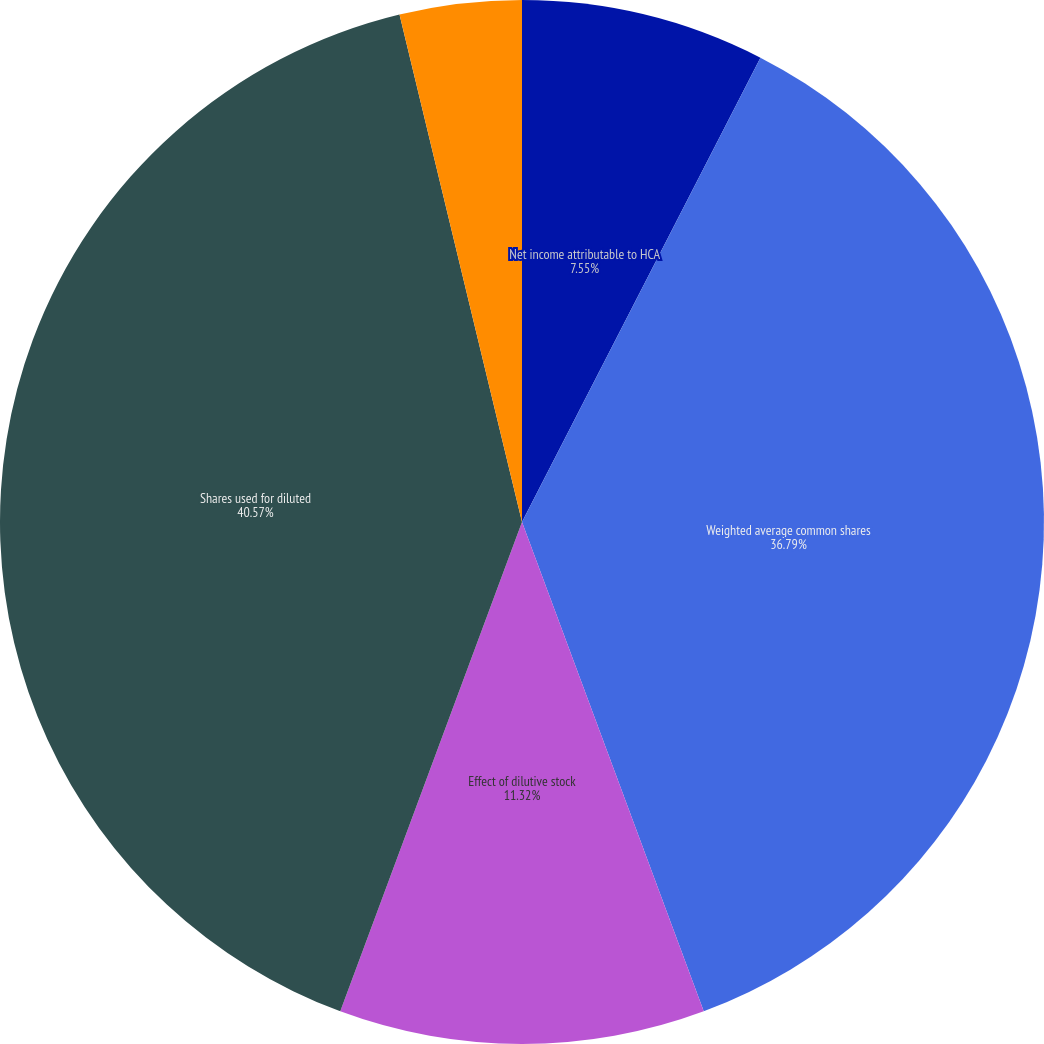Convert chart. <chart><loc_0><loc_0><loc_500><loc_500><pie_chart><fcel>Net income attributable to HCA<fcel>Weighted average common shares<fcel>Effect of dilutive stock<fcel>Shares used for diluted<fcel>Basic earnings per share<fcel>Diluted earnings per share<nl><fcel>7.55%<fcel>36.79%<fcel>11.32%<fcel>40.57%<fcel>3.77%<fcel>0.0%<nl></chart> 